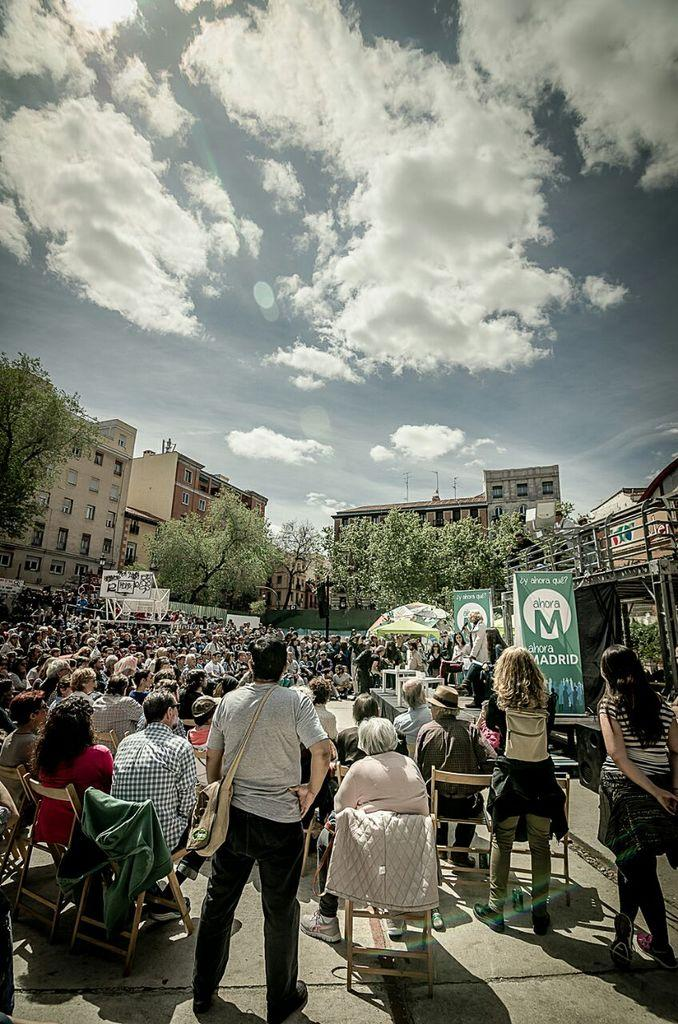What is the main activity of the people in the image? There is a group of people sitting in the image. Are there any other people visible in the image? Yes, there are three people standing behind the sitting group. What can be seen in the background of the image? There are group of trees and buildings in the background of the image. How would you describe the weather based on the image? The sky is cloudy in the image. What type of volcano can be seen in the background of the image? There is no volcano present in the image; it features a group of people sitting, standing people, trees, and buildings in the background. 